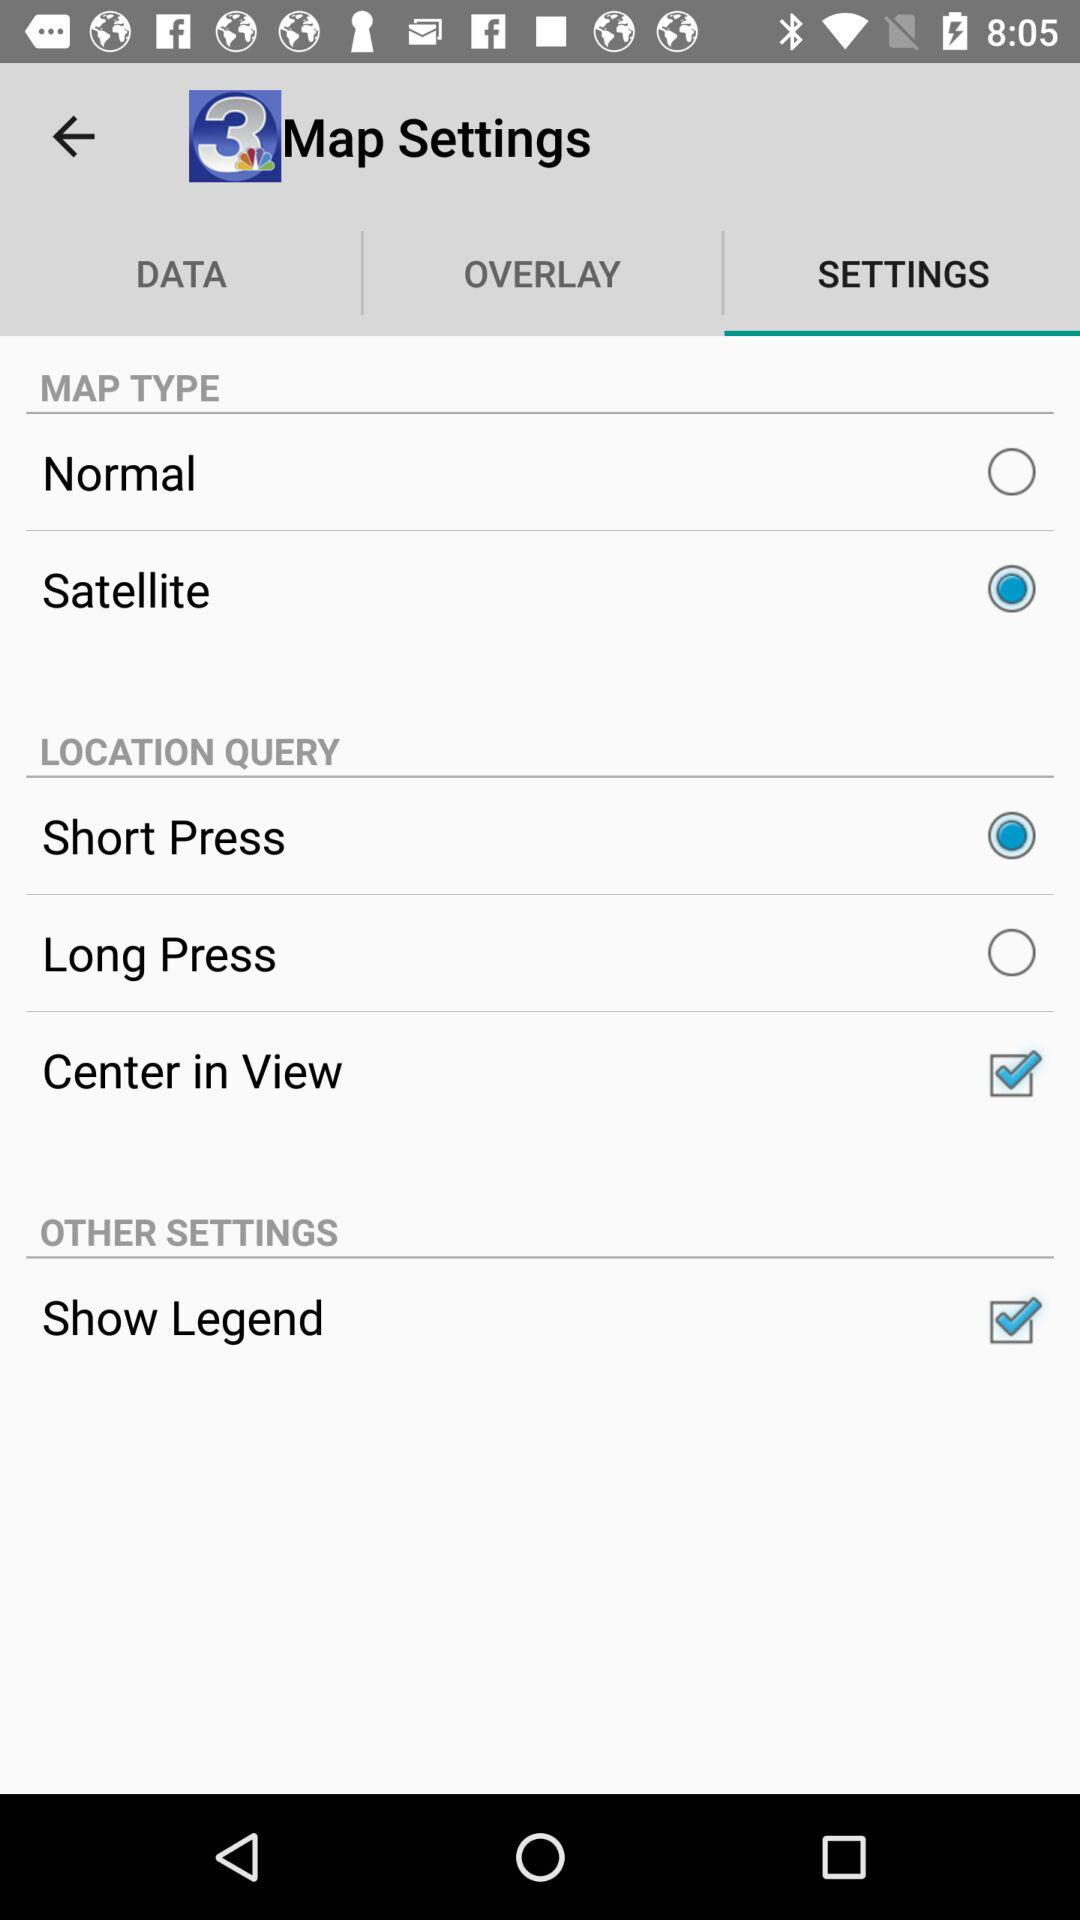What are the setting options in "MAP TYPE"? The setting options in "MAP TYPE" are "Normal" and "Satellite". 